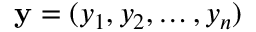Convert formula to latex. <formula><loc_0><loc_0><loc_500><loc_500>y = ( y _ { 1 } , y _ { 2 } , \dots , y _ { n } )</formula> 